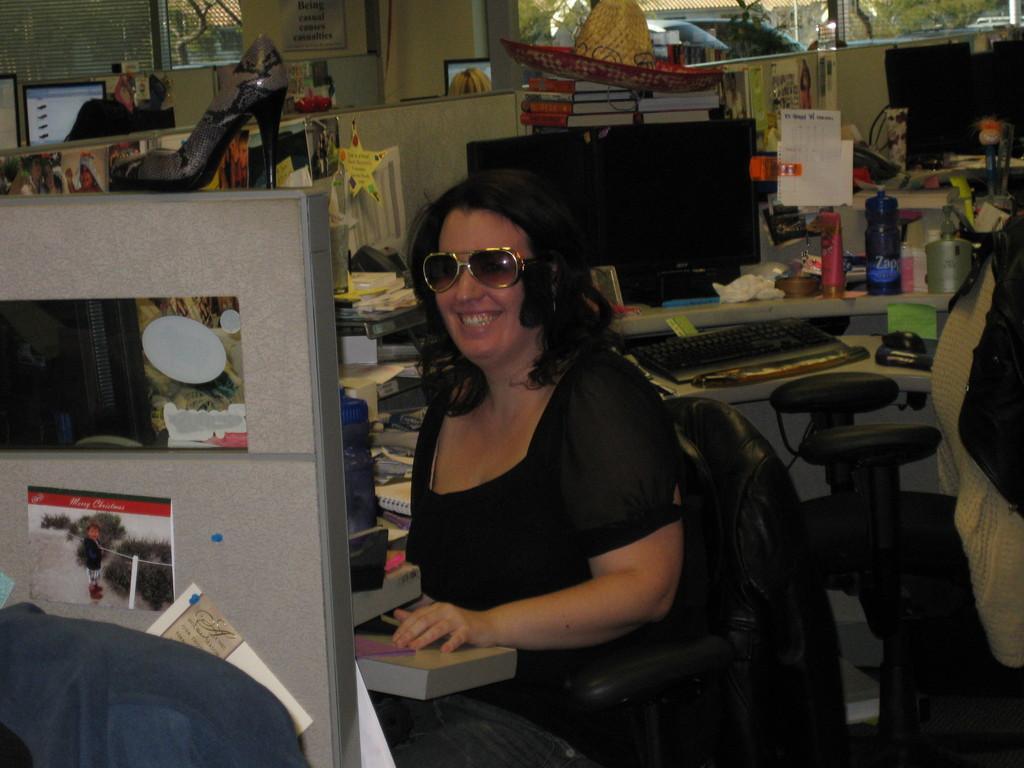In one or two sentences, can you explain what this image depicts? This picture shows a woman seated on the chair and she wore spectacles on her face and we see books, bottles and a monitor, keyboard, mouse and we see a shoe and we see few posters and we see another chair on the side and a coat on it and we see a hat on the books and we see couple of them seated and we see couple of monitors and poster on the wall and we see blinds to the window and few cars parked and we see trees. 